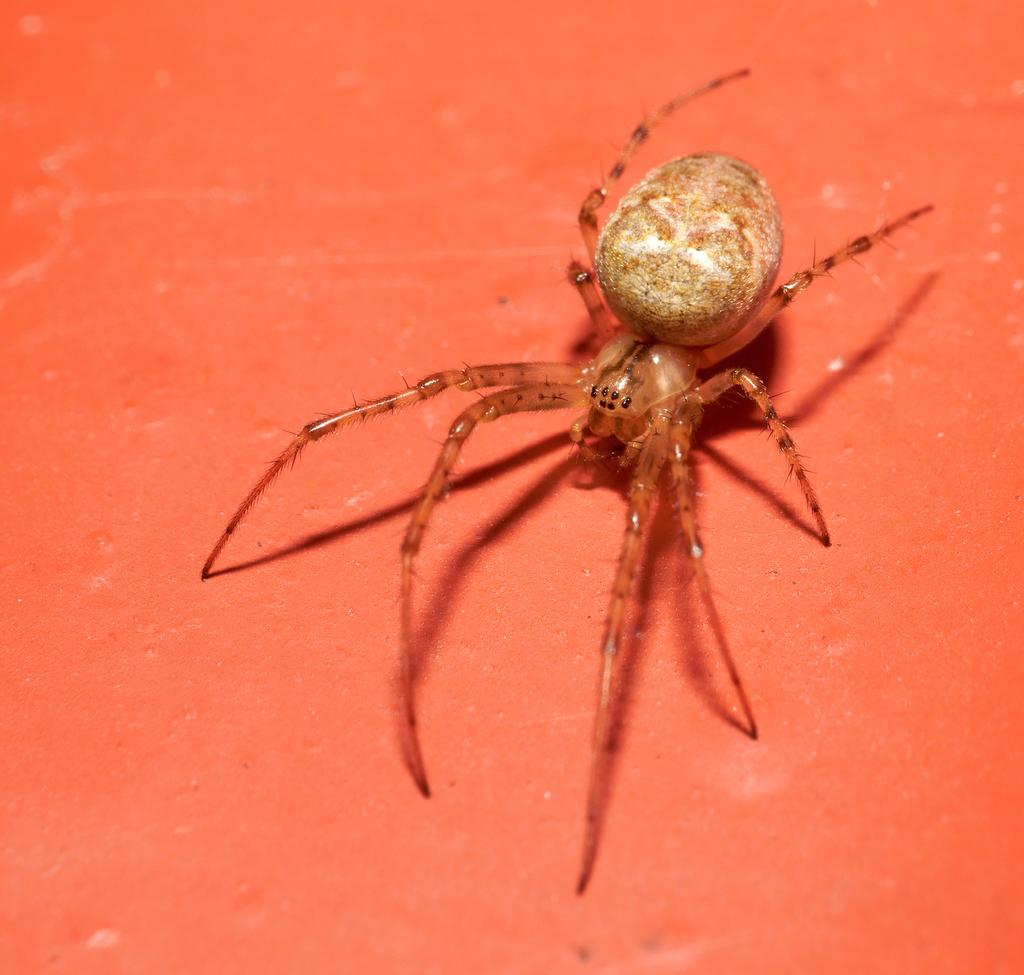What is the main subject of the image? The main subject of the image is a spider. Can you describe the spider's location in the image? The spider is on a surface in the image. What type of committee is meeting in the image? There is no committee present in the image; it features a spider on a surface. What type of quartz can be seen in the image? There is no quartz present in the image; it features a spider on a surface. 